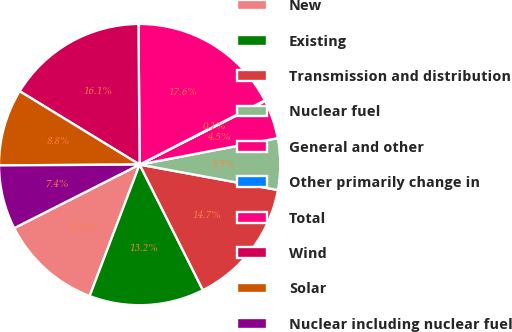<chart> <loc_0><loc_0><loc_500><loc_500><pie_chart><fcel>New<fcel>Existing<fcel>Transmission and distribution<fcel>Nuclear fuel<fcel>General and other<fcel>Other primarily change in<fcel>Total<fcel>Wind<fcel>Solar<fcel>Nuclear including nuclear fuel<nl><fcel>11.75%<fcel>13.21%<fcel>14.67%<fcel>5.91%<fcel>4.45%<fcel>0.08%<fcel>17.59%<fcel>16.13%<fcel>8.83%<fcel>7.37%<nl></chart> 